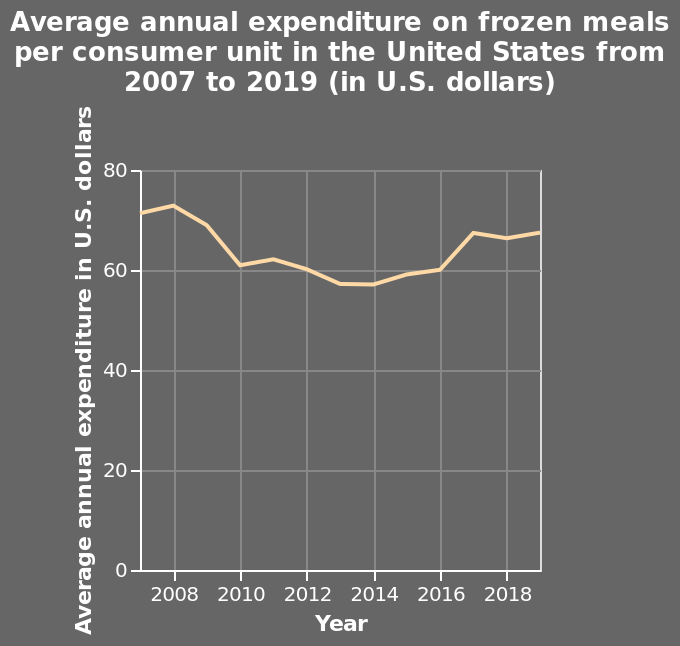<image>
When did frozen meal expenditure hit a peak?  Frozen meal expenditure hit a peak in 2008. When was there a fast decline in frozen meal expenditure?  There was a fast decline in frozen meal expenditure in 2010. What does the line in the diagram represent? The line in the diagram represents the average annual expenditure on frozen meals per consumer unit in the United States. Did frozen meal expenditure increase or decrease after 2008? Frozen meal expenditure decreased after 2008. 